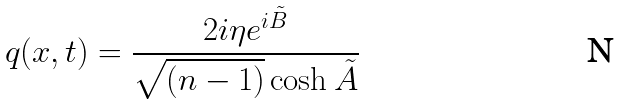Convert formula to latex. <formula><loc_0><loc_0><loc_500><loc_500>q ( x , t ) = \frac { 2 i \eta e ^ { i { \tilde { B } } } } { \sqrt { ( n - 1 ) } \cosh { \tilde { A } } }</formula> 